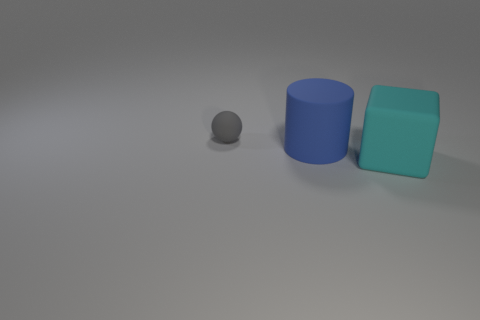Subtract all cylinders. How many objects are left? 2 Subtract 1 cylinders. How many cylinders are left? 0 Subtract all cyan things. Subtract all big cyan things. How many objects are left? 1 Add 1 gray balls. How many gray balls are left? 2 Add 1 small brown matte balls. How many small brown matte balls exist? 1 Add 2 large yellow matte cylinders. How many objects exist? 5 Subtract 0 brown spheres. How many objects are left? 3 Subtract all red cylinders. Subtract all cyan blocks. How many cylinders are left? 1 Subtract all blue blocks. How many brown cylinders are left? 0 